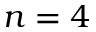Convert formula to latex. <formula><loc_0><loc_0><loc_500><loc_500>n = 4</formula> 